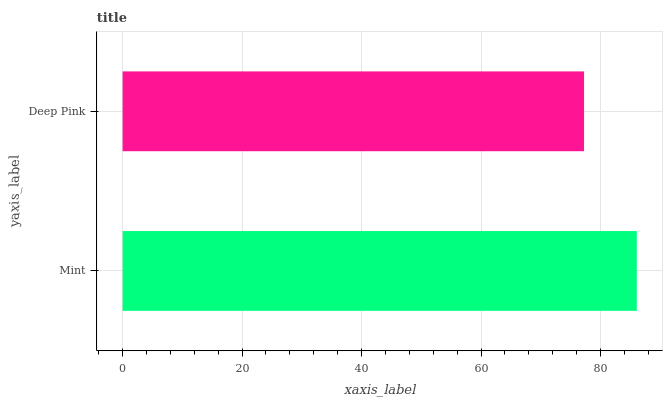Is Deep Pink the minimum?
Answer yes or no. Yes. Is Mint the maximum?
Answer yes or no. Yes. Is Deep Pink the maximum?
Answer yes or no. No. Is Mint greater than Deep Pink?
Answer yes or no. Yes. Is Deep Pink less than Mint?
Answer yes or no. Yes. Is Deep Pink greater than Mint?
Answer yes or no. No. Is Mint less than Deep Pink?
Answer yes or no. No. Is Mint the high median?
Answer yes or no. Yes. Is Deep Pink the low median?
Answer yes or no. Yes. Is Deep Pink the high median?
Answer yes or no. No. Is Mint the low median?
Answer yes or no. No. 